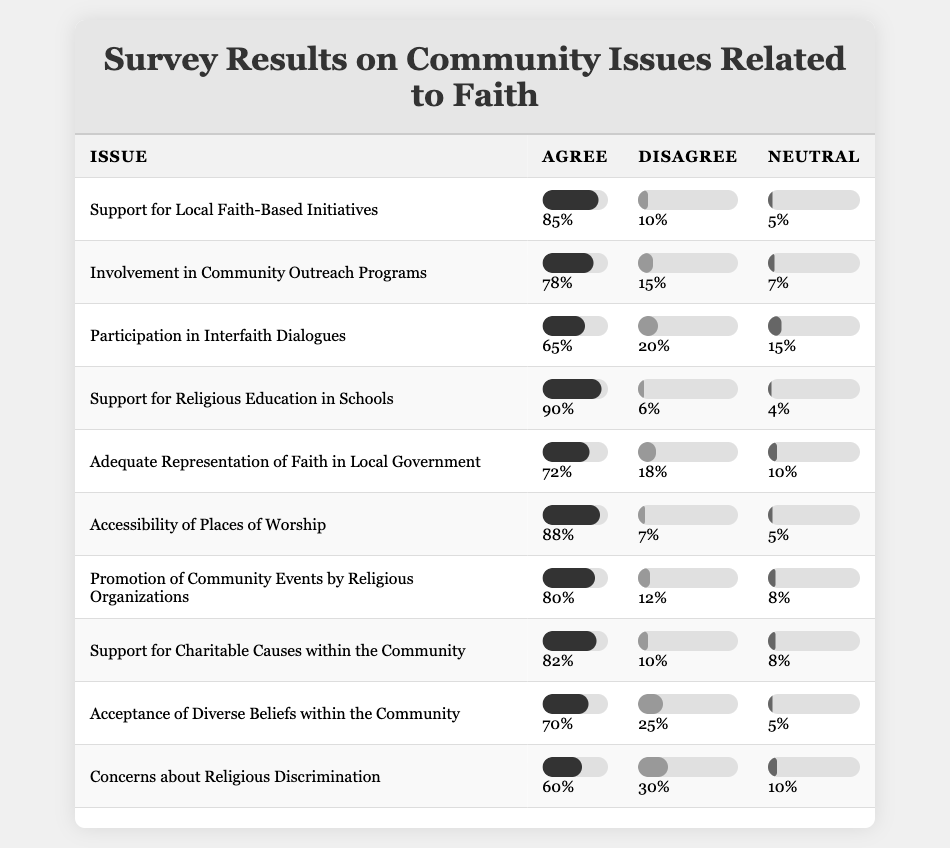What percentage of community members agreed with the support for local faith-based initiatives? The table shows that 85% of participants agreed with the support for local faith-based initiatives.
Answer: 85% What is the percentage of disagreement regarding participation in interfaith dialogues? The table indicates that 20% of respondents disagree with participation in interfaith dialogues.
Answer: 20% What percentage of respondents felt neutral about the adequacy of representation of faith in local government? According to the table, 10% of respondents felt neutral about the adequacy of representation of faith in local government.
Answer: 10% Which issue received the highest percentage of agreement? By examining the table, support for religious education in schools received the highest agreement at 90%.
Answer: 90% Calculate the average percentage of agreement for the issues listed in the table. The total percentage of agreement for all issues is (85 + 78 + 65 + 90 + 72 + 88 + 80 + 82 + 70 + 60) = 800. There are 10 issues, so the average is 800 / 10 = 80.
Answer: 80 Is there more concern about religious discrimination than support for local faith-based initiatives? The table shows that 60% of respondents are concerned about religious discrimination while 85% support local faith-based initiatives. Since 60% is less than 85%, there is less concern about religious discrimination.
Answer: No Which issues show a higher percentage of agreement, accessibility of places of worship or involvement in community outreach programs? Accessibility of places of worship has 88% agreement while involvement in community outreach programs has 78% agreement. Since 88% is greater than 78%, accessibility of places of worship shows higher agreement.
Answer: Accessibility of places of worship If we combine the disagree percentages for the two issues with the lowest agreement, what is the total? The two issues with the lowest agreement are "Concerns about Religious Discrimination" (30% disagree) and "Participation in Interfaith Dialogues" (20% disagree). Adding these percentages gives 30 + 20 = 50%.
Answer: 50% How does the percentage of respondents who agree with charitable causes compare to those who disagree? The table shows that 82% agree with charitable causes while 10% disagree. The agreement percentage (82%) is significantly higher than the disagreement percentage (10%).
Answer: Higher agreement What is the difference in agreement percentages between support for religious education in schools and acceptance of diverse beliefs? Support for religious education in schools has 90% agreement while acceptance of diverse beliefs has 70% agreement. The difference is 90 - 70 = 20%.
Answer: 20% 